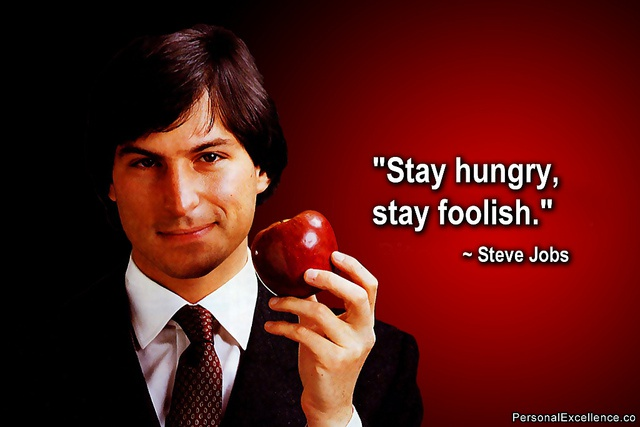Describe the objects in this image and their specific colors. I can see people in black, maroon, and tan tones, apple in black, maroon, and brown tones, and tie in black, maroon, and brown tones in this image. 